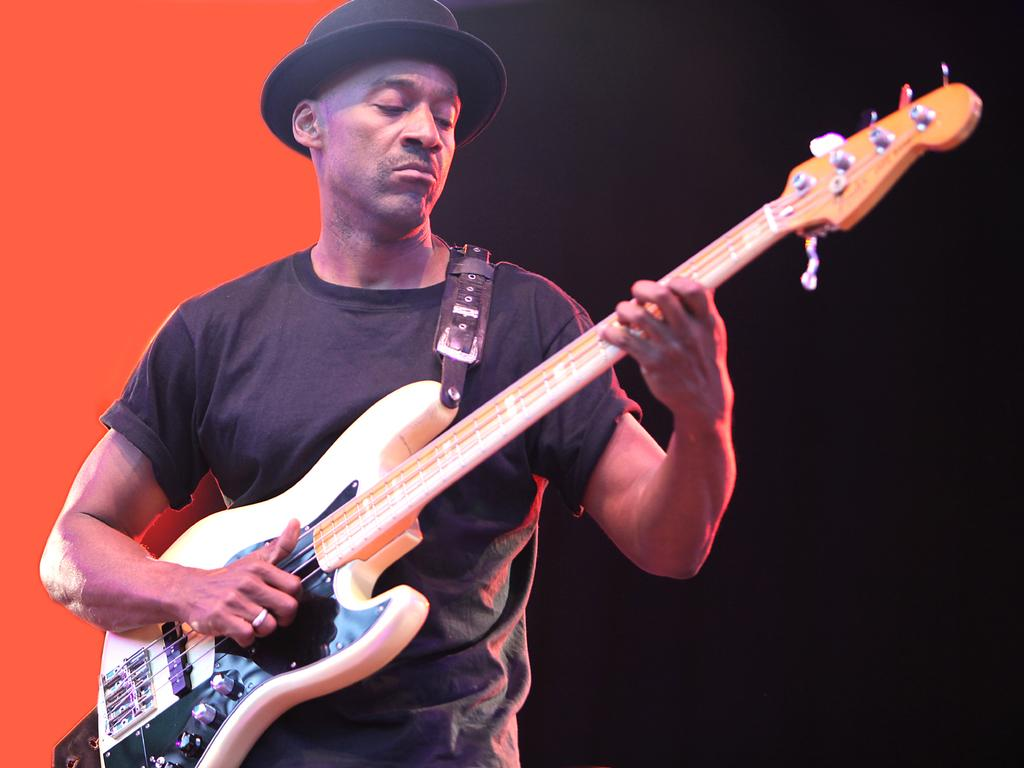What is the main subject of the image? The main subject of the image is a man. What is the man wearing in the image? The man is wearing a black shirt in the image. What is the man holding in the image? The man is holding a guitar in the image. What is the man doing with the guitar? The man is playing the guitar in the image. What accessory is the man wearing on his head? The man has a hat on his head in the image. What type of punishment is the man receiving for playing the guitar in the image? There is no indication of punishment in the image; the man is playing the guitar voluntarily. What type of marble is the man using to play the guitar in the image? The man is not using any marble to play the guitar in the image; he is using his fingers or a pick. 